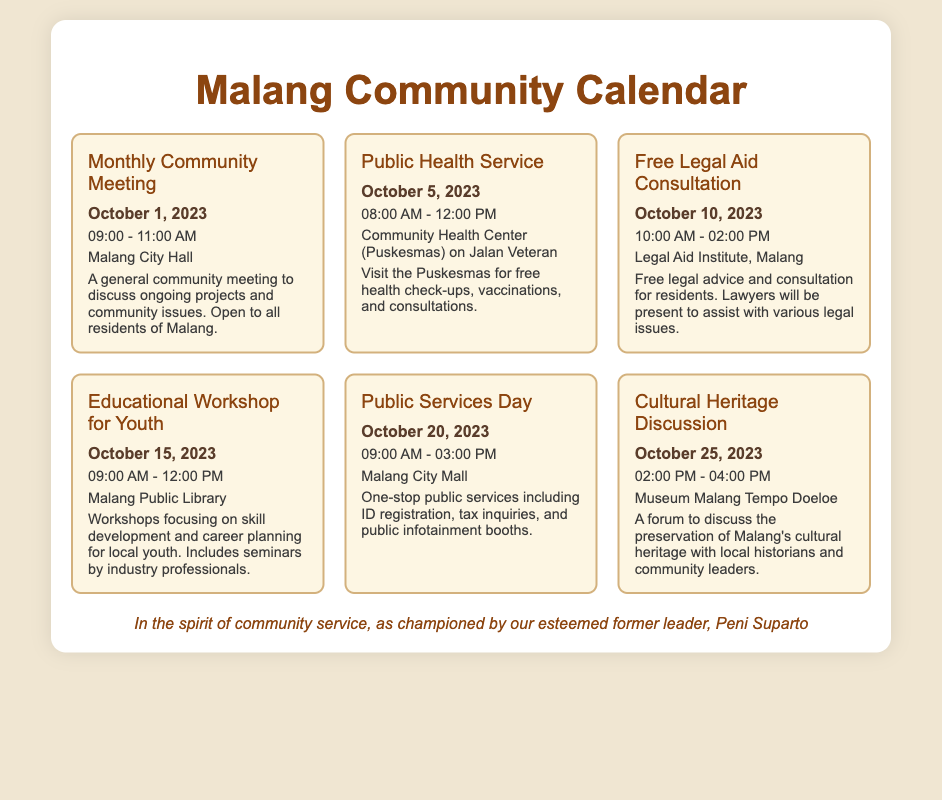What is the date of the Monthly Community Meeting? The date is specified in the event information for the Monthly Community Meeting.
Answer: October 1, 2023 What time does the Public Health Service start? The start time is given in the event details for the Public Health Service.
Answer: 08:00 AM Where is the Educational Workshop for Youth held? The location is mentioned in the event description for the Educational Workshop for Youth.
Answer: Malang Public Library How long is the Public Services Day scheduled for? The duration can be calculated based on the start and end times listed for Public Services Day.
Answer: 6 hours Which event focuses on cultural preservation? The title and description of the event indicate the focus area of cultural preservation.
Answer: Cultural Heritage Discussion What services are offered during the Public Services Day? The event description outlines the specific public services available during this event.
Answer: ID registration, tax inquiries, public infotainment booths What is the time of the Free Legal Aid Consultation event? The time is specified in the event information for the Free Legal Aid Consultation.
Answer: 10:00 AM - 02:00 PM Who is recognized for championing community service in the document? The footer of the document attributes the spirit of community service to a specific individual.
Answer: Peni Suparto 